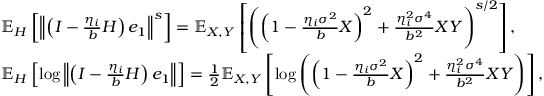<formula> <loc_0><loc_0><loc_500><loc_500>\begin{array} { r l } & { \mathbb { E } _ { H } \left [ \left \| \left ( I - \frac { \eta _ { i } } { b } H \right ) e _ { 1 } \right \| ^ { s } \right ] = \mathbb { E } _ { X , Y } \left [ \left ( \left ( 1 - \frac { \eta _ { i } \sigma ^ { 2 } } { b } X \right ) ^ { 2 } + \frac { \eta _ { i } ^ { 2 } \sigma ^ { 4 } } { b ^ { 2 } } X Y \right ) ^ { s / 2 } \right ] , } \\ & { \mathbb { E } _ { H } \left [ \log \left \| \left ( I - \frac { \eta _ { i } } { b } H \right ) e _ { 1 } \right \| \right ] = \frac { 1 } { 2 } \mathbb { E } _ { X , Y } \left [ \log \left ( \left ( 1 - \frac { \eta _ { i } \sigma ^ { 2 } } { b } X \right ) ^ { 2 } + \frac { \eta _ { i } ^ { 2 } \sigma ^ { 4 } } { b ^ { 2 } } X Y \right ) \right ] , } \end{array}</formula> 